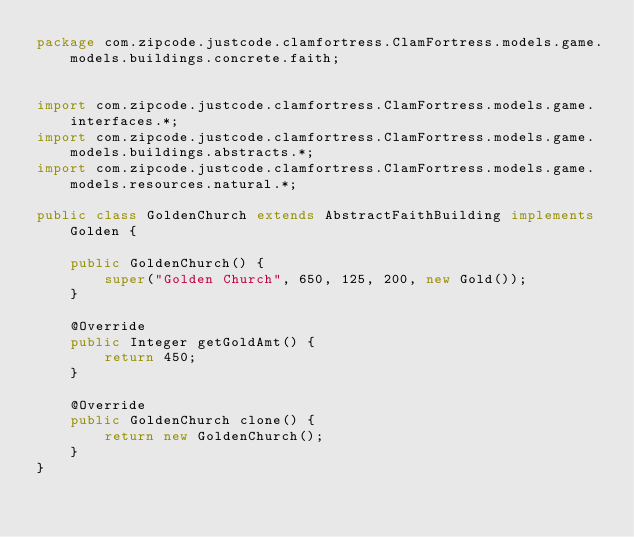<code> <loc_0><loc_0><loc_500><loc_500><_Java_>package com.zipcode.justcode.clamfortress.ClamFortress.models.game.models.buildings.concrete.faith;


import com.zipcode.justcode.clamfortress.ClamFortress.models.game.interfaces.*;
import com.zipcode.justcode.clamfortress.ClamFortress.models.game.models.buildings.abstracts.*;
import com.zipcode.justcode.clamfortress.ClamFortress.models.game.models.resources.natural.*;

public class GoldenChurch extends AbstractFaithBuilding implements Golden {

    public GoldenChurch() {
        super("Golden Church", 650, 125, 200, new Gold());
    }

    @Override
    public Integer getGoldAmt() {
        return 450;
    }

    @Override
    public GoldenChurch clone() {
        return new GoldenChurch();
    }
}
</code> 